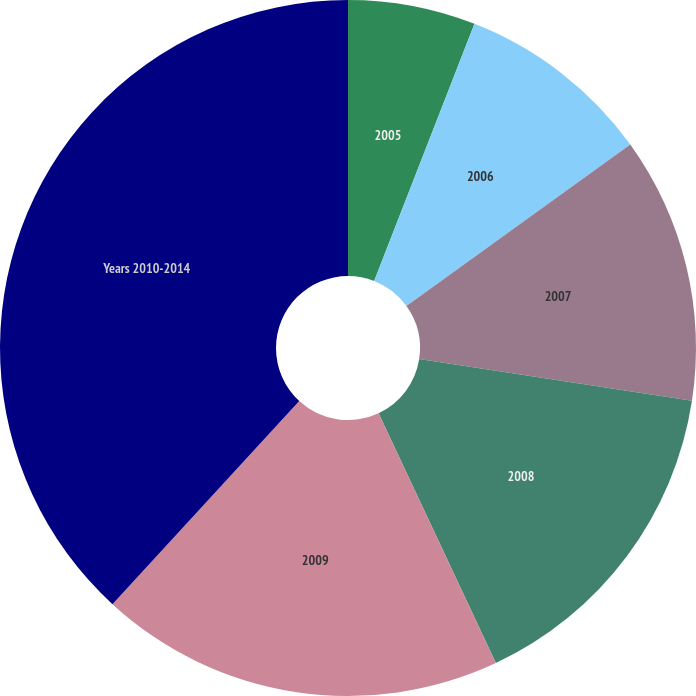Convert chart to OTSL. <chart><loc_0><loc_0><loc_500><loc_500><pie_chart><fcel>2005<fcel>2006<fcel>2007<fcel>2008<fcel>2009<fcel>Years 2010-2014<nl><fcel>5.92%<fcel>9.14%<fcel>12.37%<fcel>15.59%<fcel>18.82%<fcel>38.17%<nl></chart> 